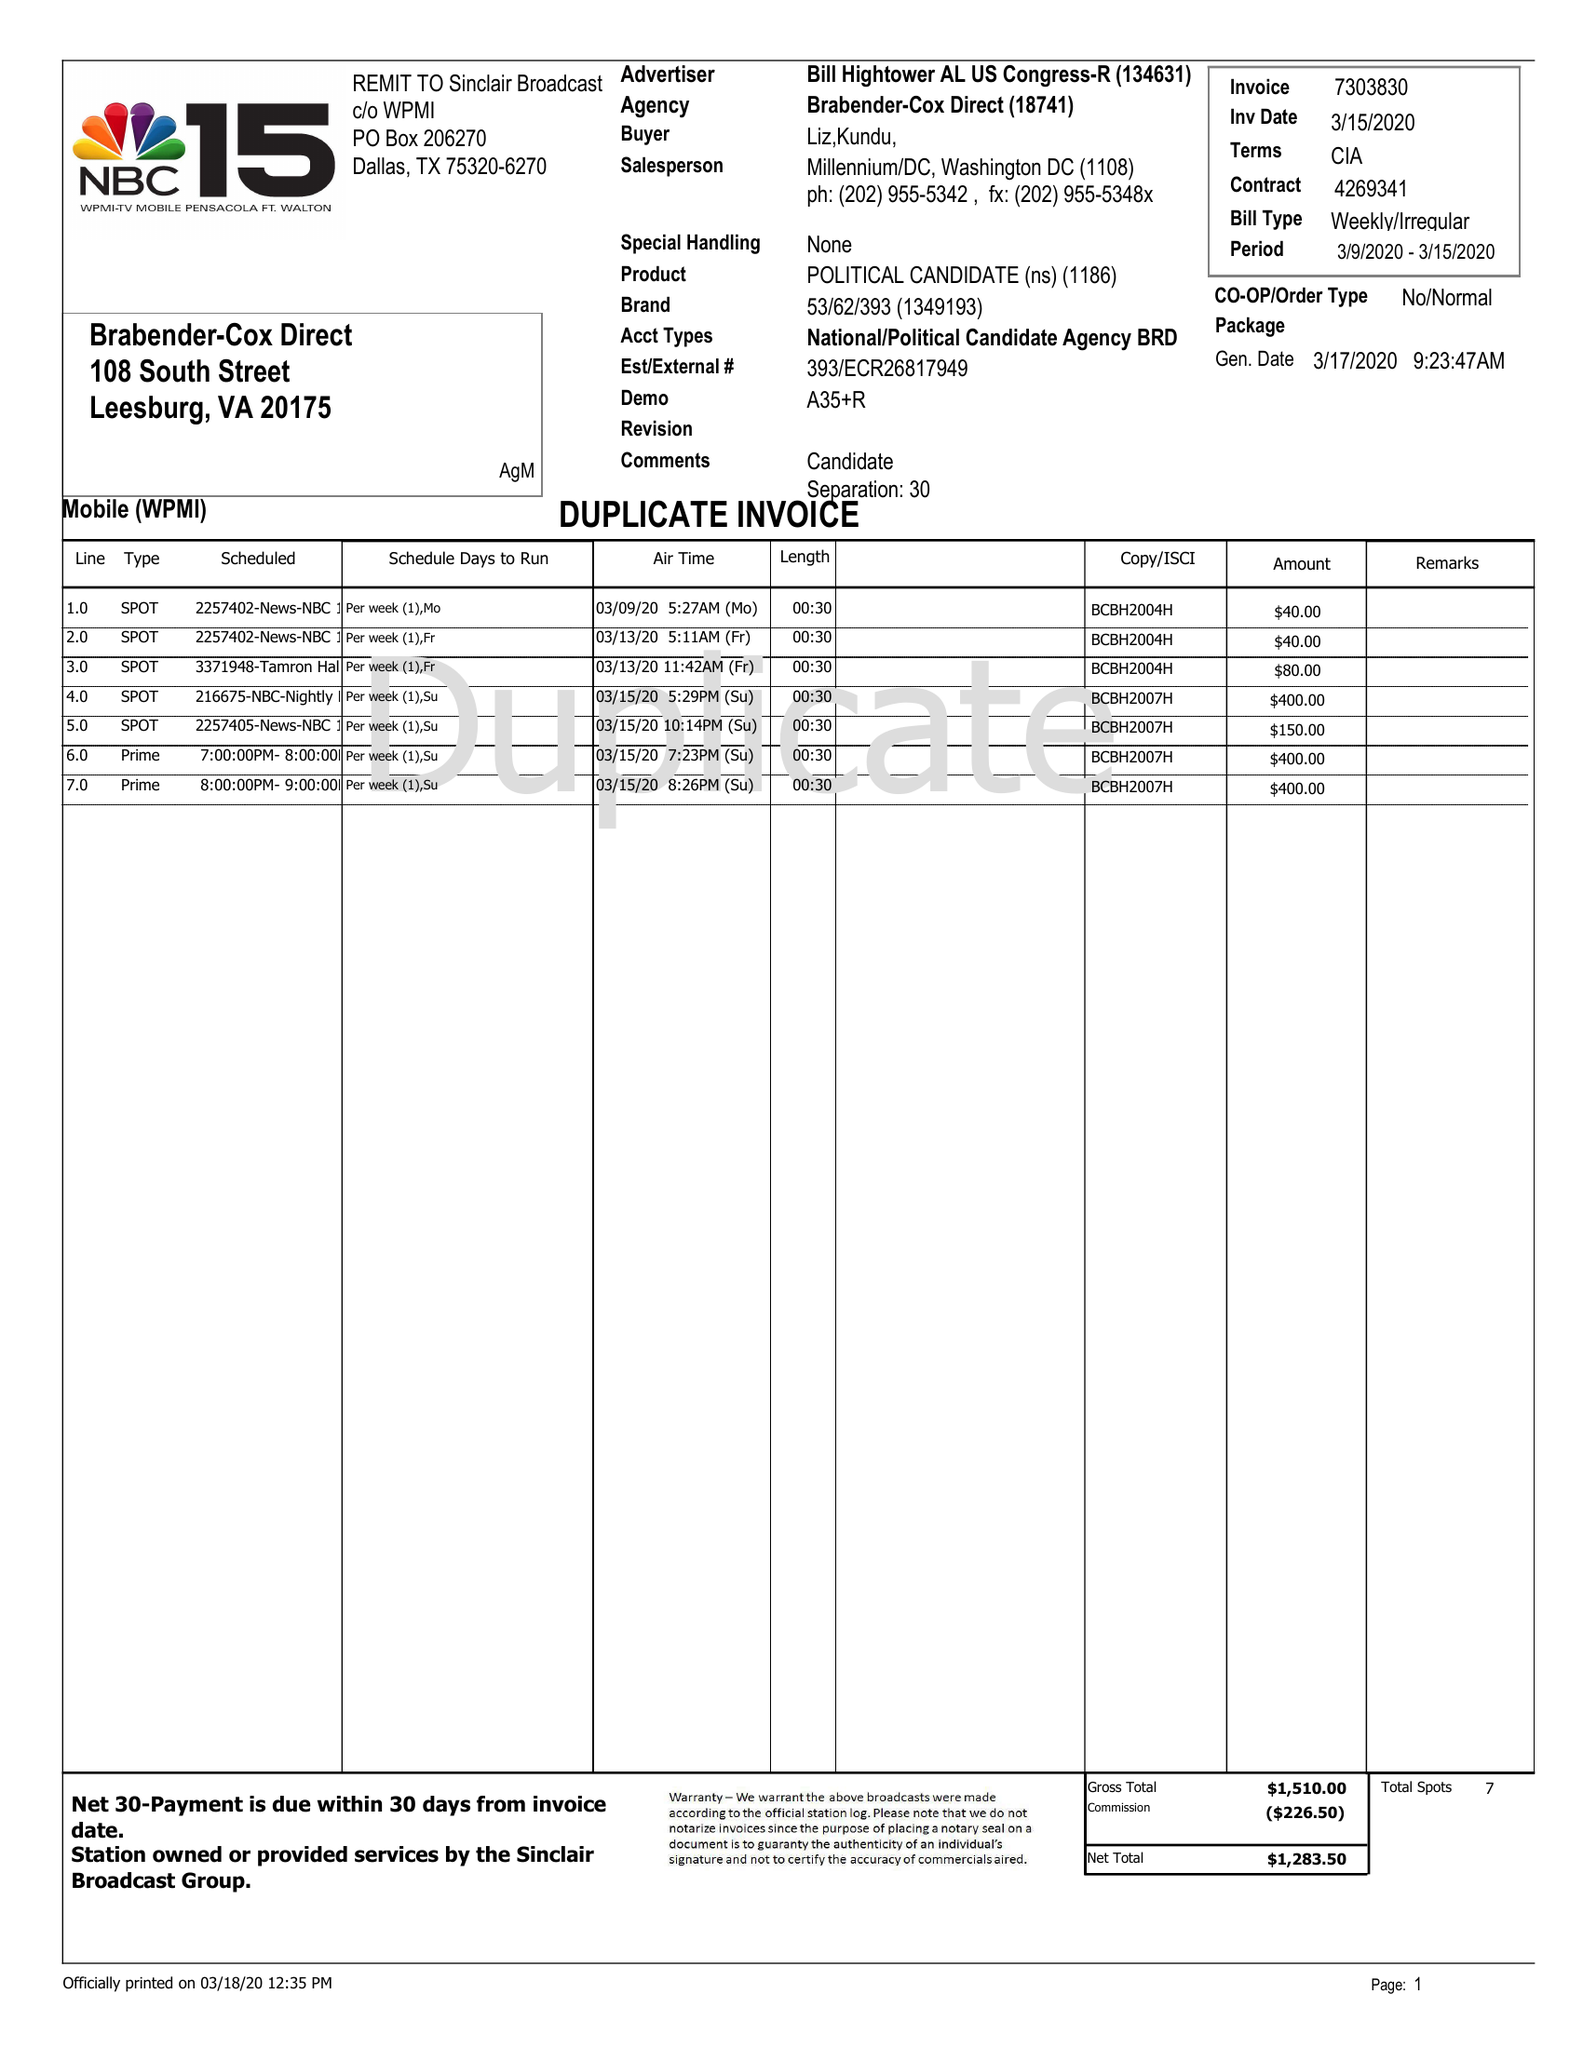What is the value for the gross_amount?
Answer the question using a single word or phrase. 1510.00 